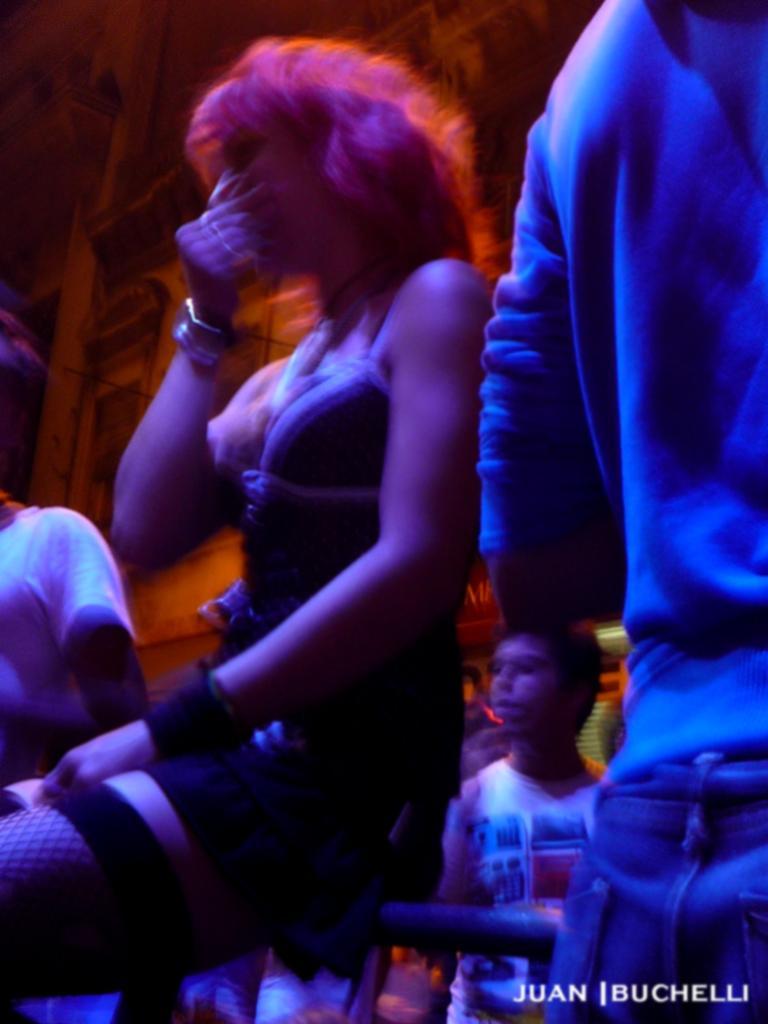Can you describe this image briefly? On the left side, there is a woman sitting on the pole. On the right side, there is a person standing. In the right bottom corner, there is a watermark. In the background, there are persons. And the background is dark in color. 